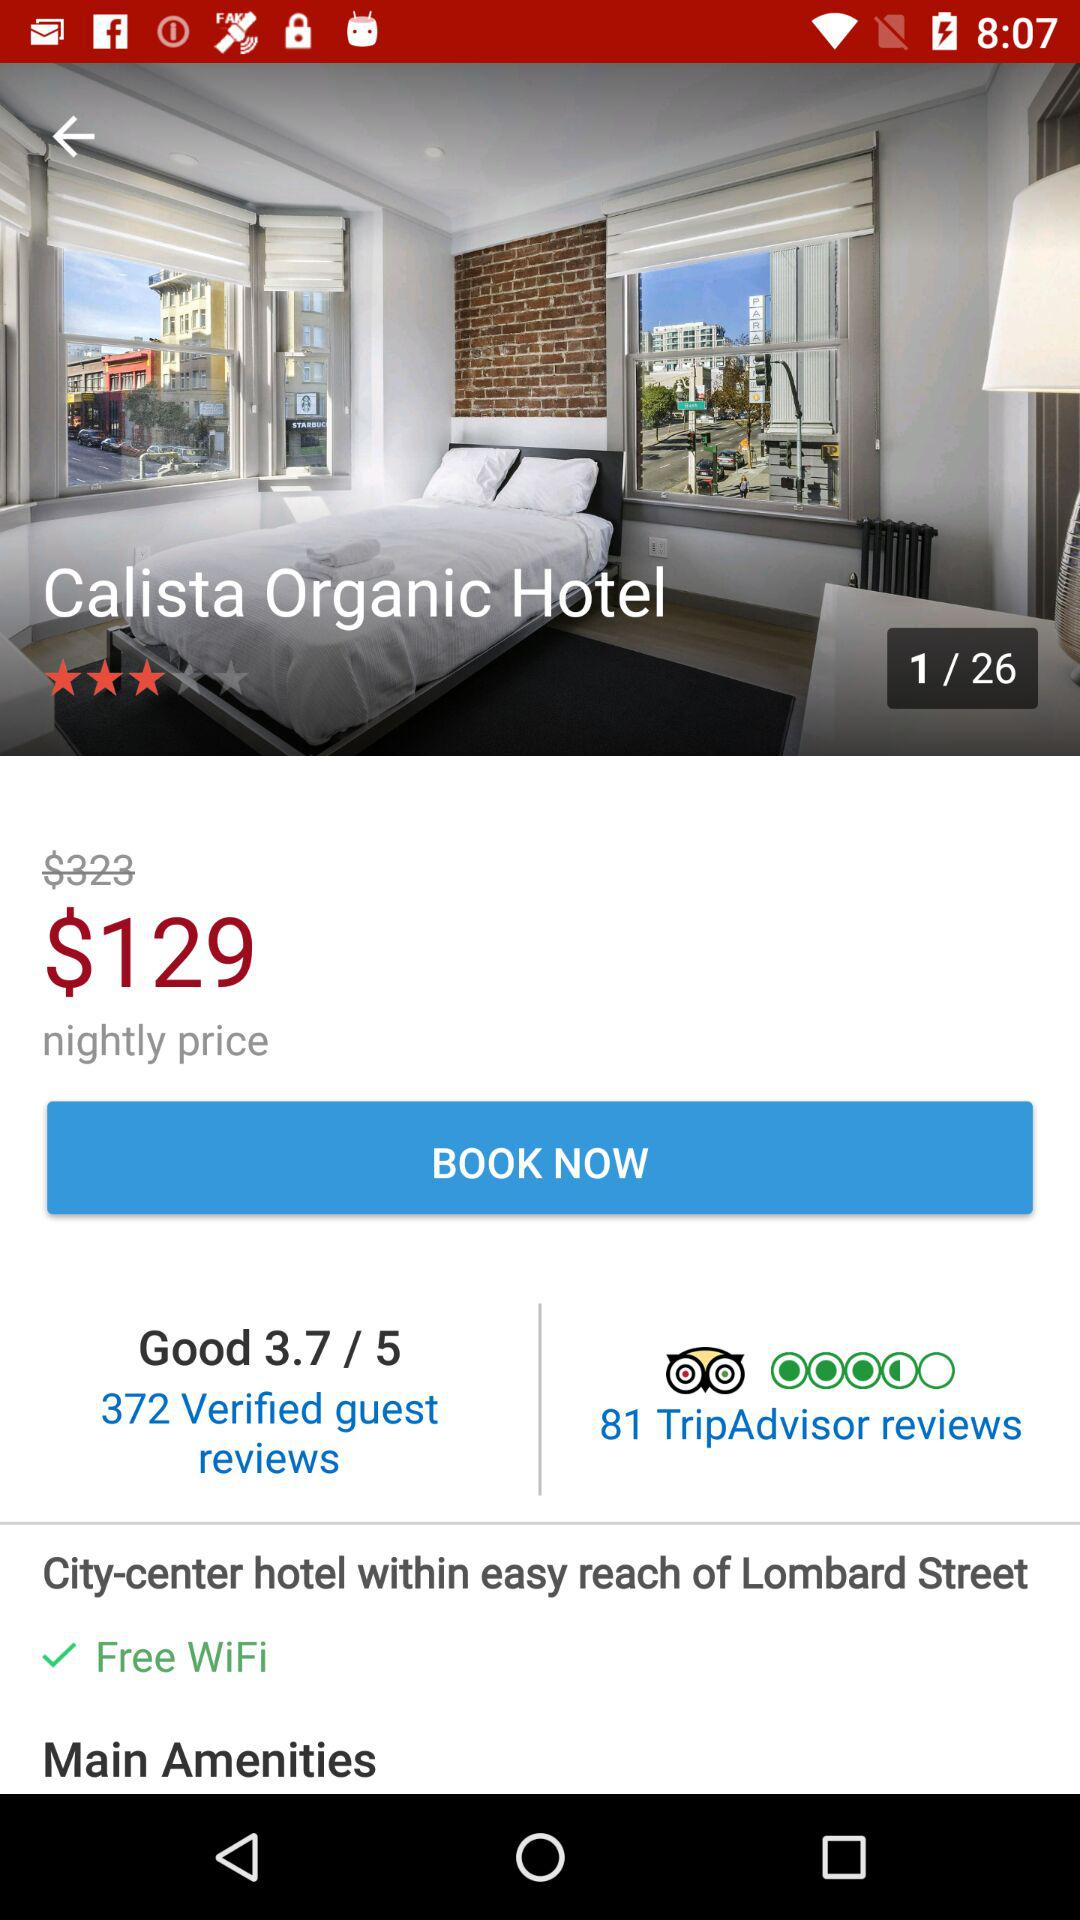What is the night price? The night price is $129. 